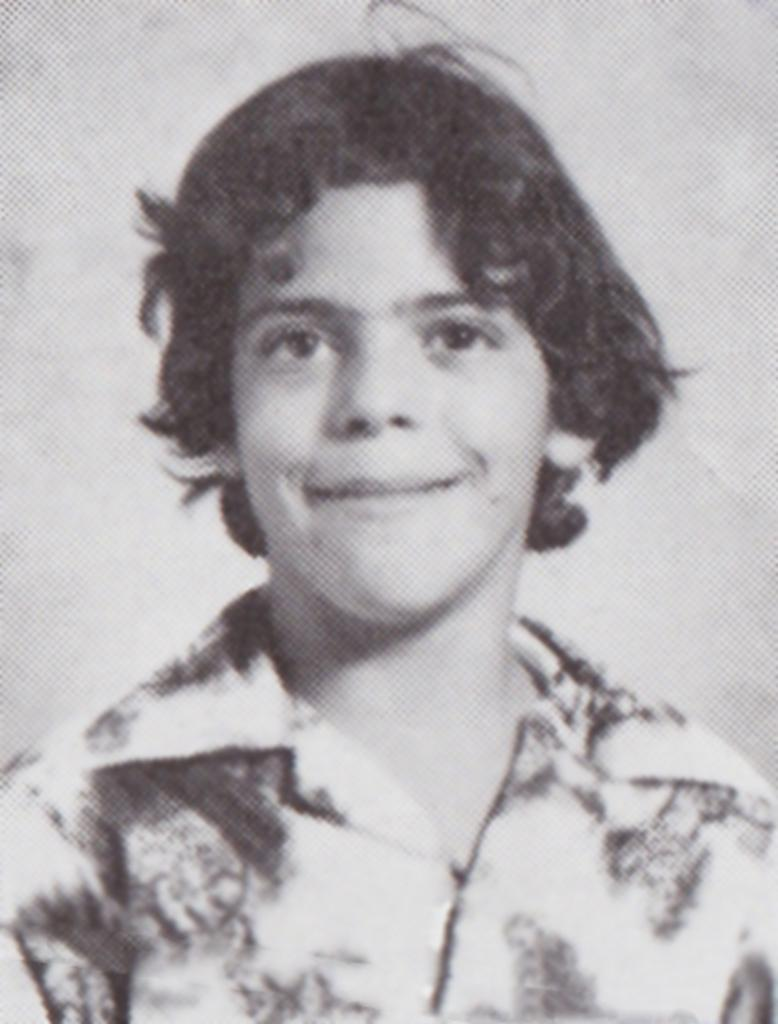What is the color scheme of the image? The image is black and white. Who is present in the image? There is a man in the image. What is the man wearing? The man is wearing a shirt. What color is the background of the image? The background of the image is white in color. Can you tell me how many crows are perched on the man's shoulder in the image? There are no crows present in the image; it features a man wearing a shirt against a white background. What type of request is the man making in the image? There is no indication of a request being made in the image, as it only shows a man wearing a shirt against a white background. 